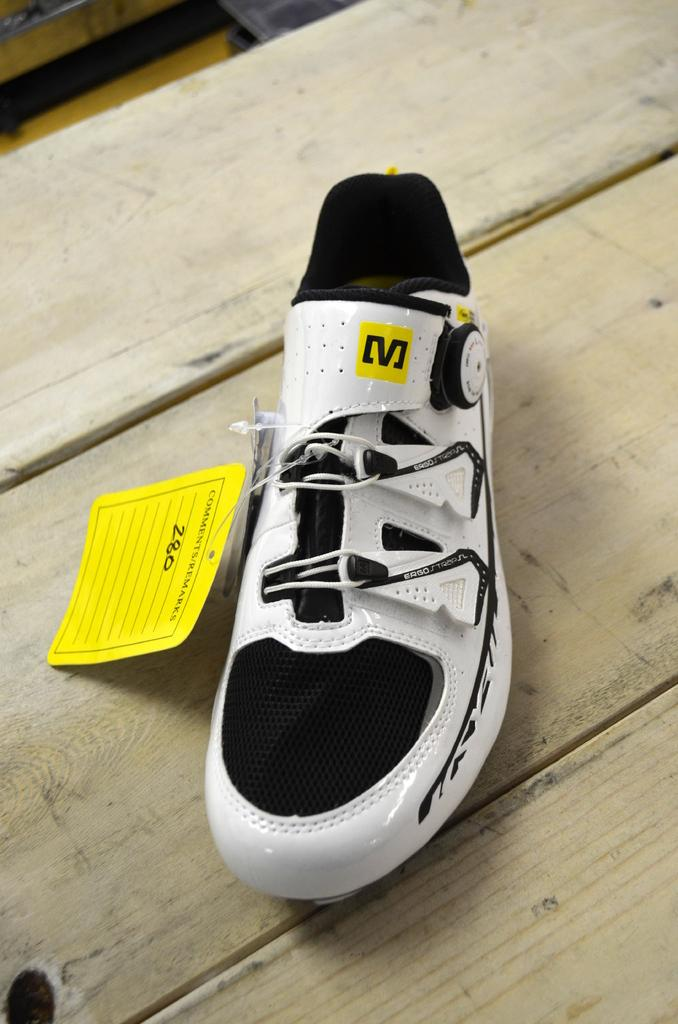What object is present in the image? There is a shoe in the image. Is there any additional information about the shoe? Yes, the shoe has a tag. Where is the shoe located in the image? The shoe is placed on a wooden table. What letter does the shoe's owner prefer to receive? There is no information about the shoe's owner or their preferences in the image. 